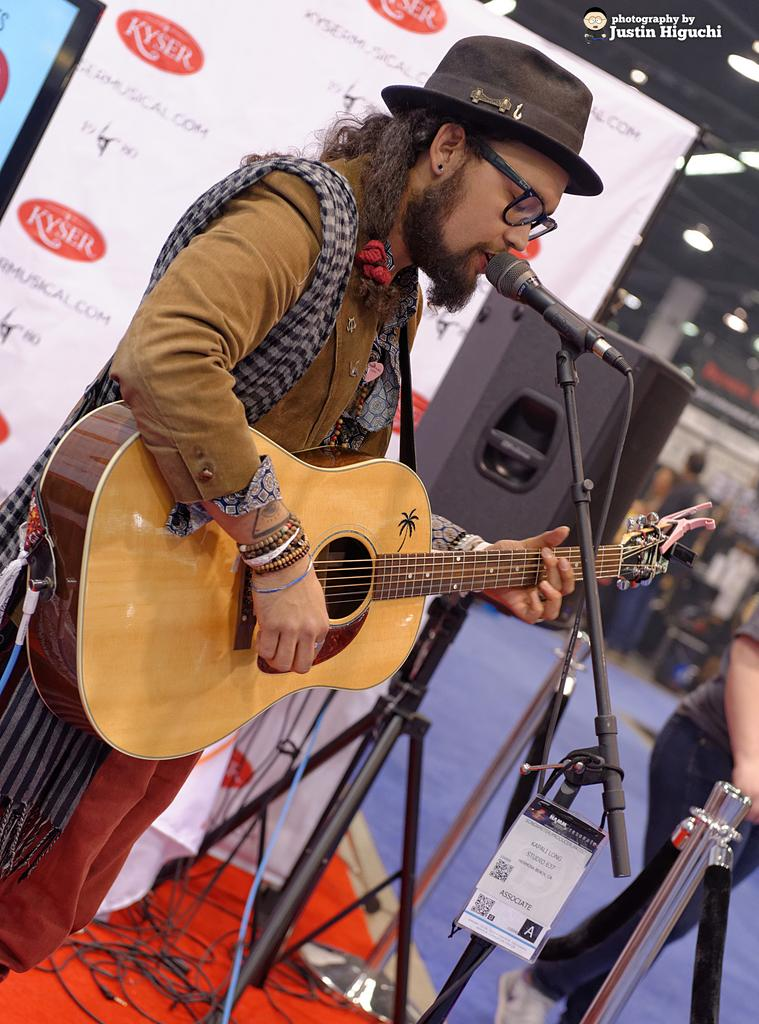What is the man in the image doing? The man is standing and playing a guitar. What is the man positioned in front of? The man is in front of a microphone. Can you describe the man's clothing? The man is wearing a jacket, spectacles, and a hat. What additional objects can be seen in the image? There are banners, another person standing, and a speaker with a stand in the image. What type of power does the man's brain generate while playing the guitar? There is no information about the man's brain or its power generation in the image. 